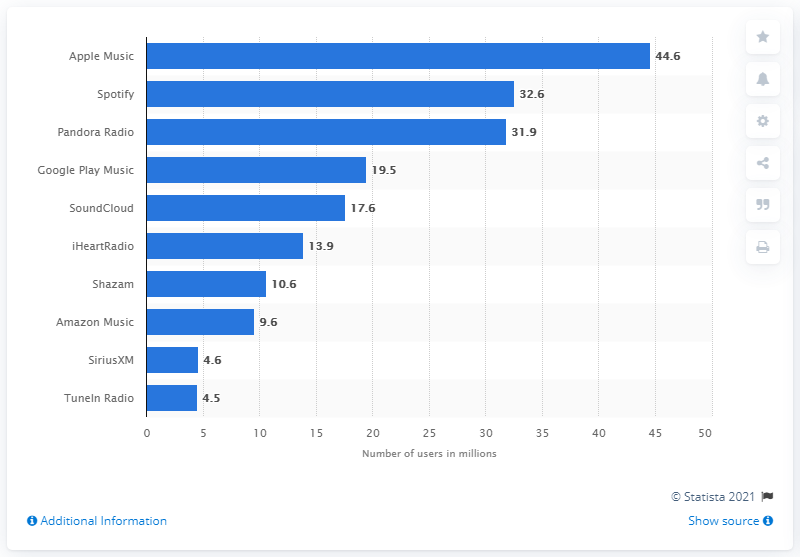Point out several critical features in this image. In March 2018, the Apple Music service was used by approximately 44,600 people. 